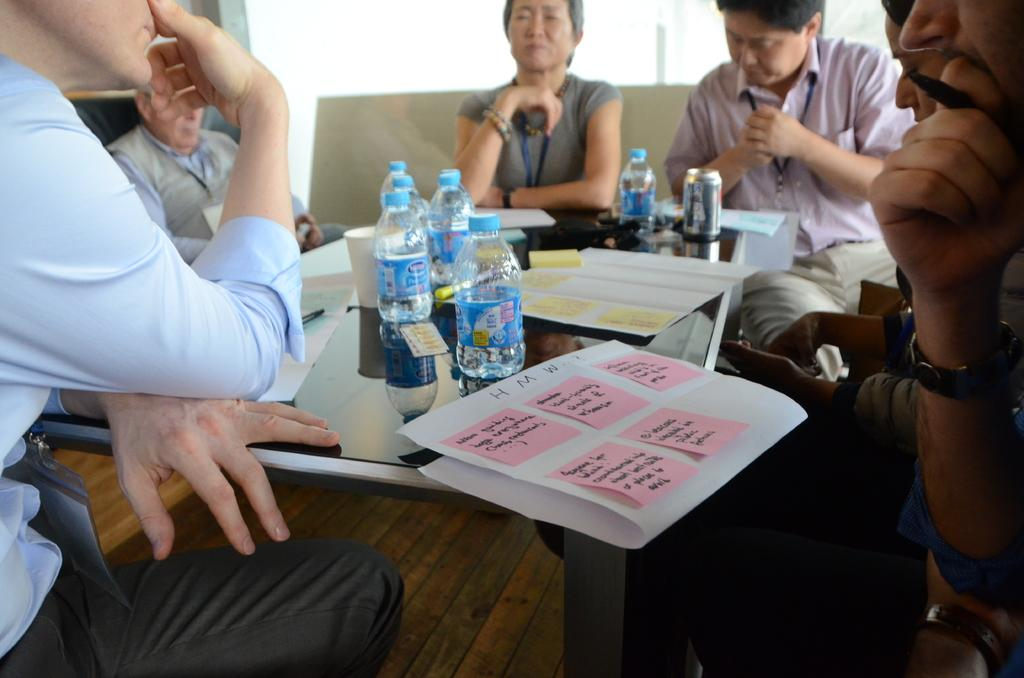What are the people in the image doing? There is a group of people seated in the image. What items can be seen for hydration in the image? Water bottles are visible in the image. What else can be seen for drinking in the image? There are cups in the image. What items can be seen on the table in the image? There are papers on the table in the image. What type of bread can be seen on the playground in the image? There is no playground or bread present in the image. 